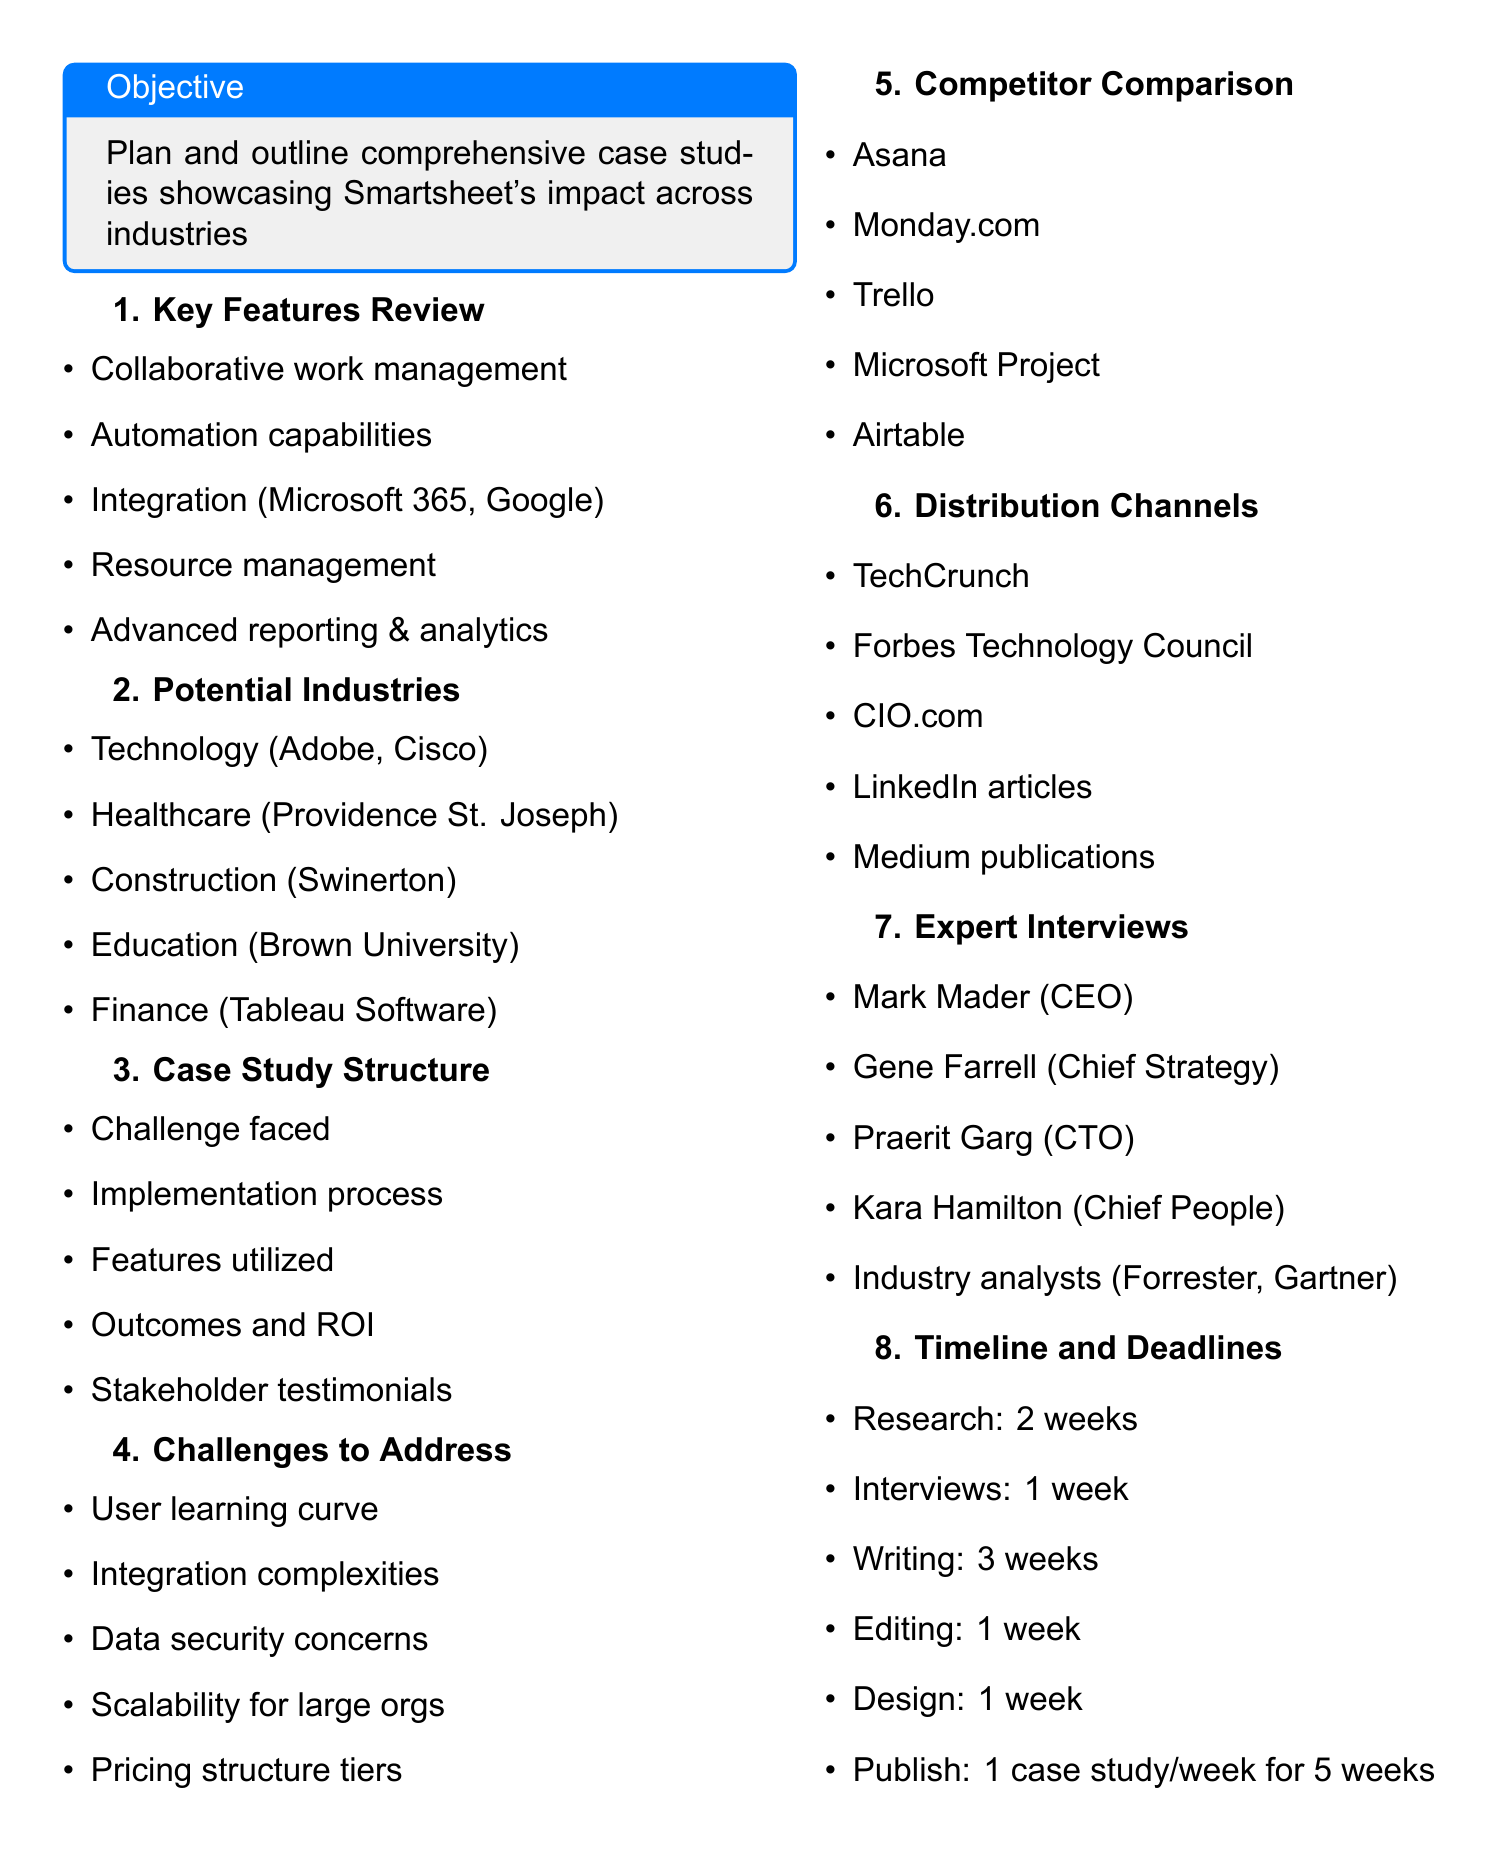What is the meeting title? The meeting title is provided at the top of the document.
Answer: Editorial Brainstorming Session for Upcoming Smartsheet Case Study Series How many potential case study industries are listed? The document enumerates the industries under the agenda item "Potential Case Study Industries."
Answer: Five Who is the CEO of Smartsheet? The document lists key experts, including their titles and names.
Answer: Mark Mader What is the first item in the case study structure? The case study structure outlines several components, with the first being specified.
Answer: Challenge faced by the organization Which competitor is mentioned last in the comparison? The list of competitors is provided in a specific order, and the last one can be identified.
Answer: Airtable What is the publication schedule for the case studies? The timeline section details the frequency and duration of case study releases.
Answer: One case study per week for 5 weeks What is one potential challenge to address? The potential challenges are listed, and this asks for one of those listed items.
Answer: Learning curve for new users How long is the research phase? The timeline itemizes the duration for each step, with research being specified.
Answer: Two weeks 